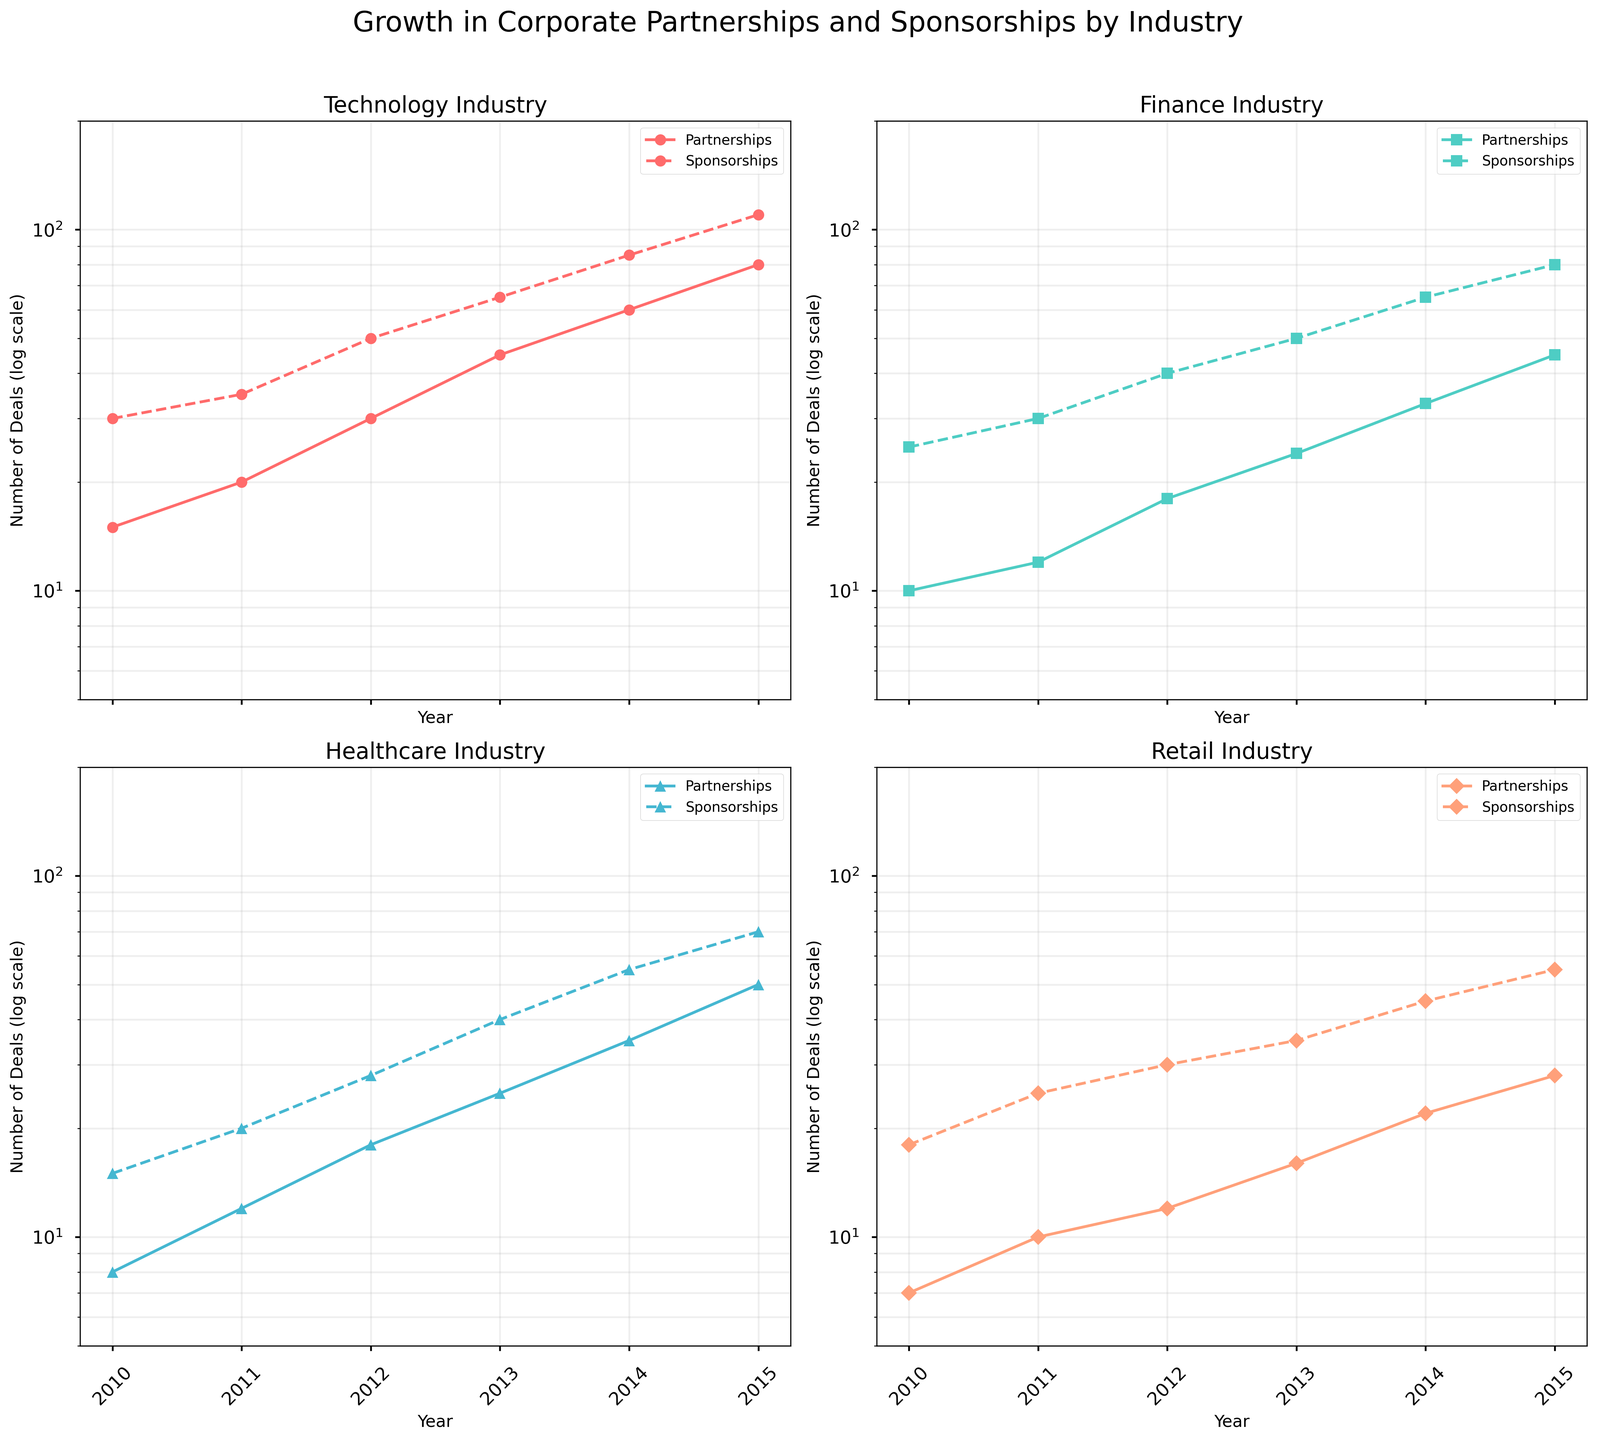What is the title of the figure? The title is usually located at the top of the figure. In this case, it says "Growth in Corporate Partnerships and Sponsorships by Industry".
Answer: Growth in Corporate Partnerships and Sponsorships by Industry Which industry saw the highest number of partnerships in 2015? Look at the subplots for each industry and find the data point in year 2015 for partnerships. The Technology industry subplot shows 80 partnerships.
Answer: Technology How many sponsorships did the Finance industry have in 2013? Identify the subplot for Finance and locate the 2013 point on the Sponsorships curve, which is distinguishable by a dashed line. The value is 50.
Answer: 50 Compare the growth trends for partnerships between Technology and Retail industries. Which one shows a steeper increase? For both industries, analyze the slopes of the partnerships curves. The Technology industry shows a steeper increase compared to the Retail industry.
Answer: Technology Which year shows the largest increase in partnerships for the Healthcare industry and how many were there in that year? Check the Healthcare subplot for the rate of change in partnerships. Between 2012 and 2013, there is a significant increase from 18 to 25.
Answer: 2013, 25 What is the pattern of sponsorship growth in the Technology industry from 2010 to 2015? View the curve for sponsorships in the Technology subplot. It shows a consistent upward trend from 30 in 2010 to 110 in 2015.
Answer: Consistent upward trend Between Finance and Healthcare industries, which had lesser partnerships in 2014? Compare the 2014 data points for partnerships in both industries from their respective subplots. Finance had 33 and Healthcare had 35, so Finance had lesser partnerships.
Answer: Finance For the Retail industry, in which year did partnerships surpass 10? Locate the Retail subplot and find the first year where partnerships exceed 10. This occurs in 2011 with 12 partnerships.
Answer: 2011 